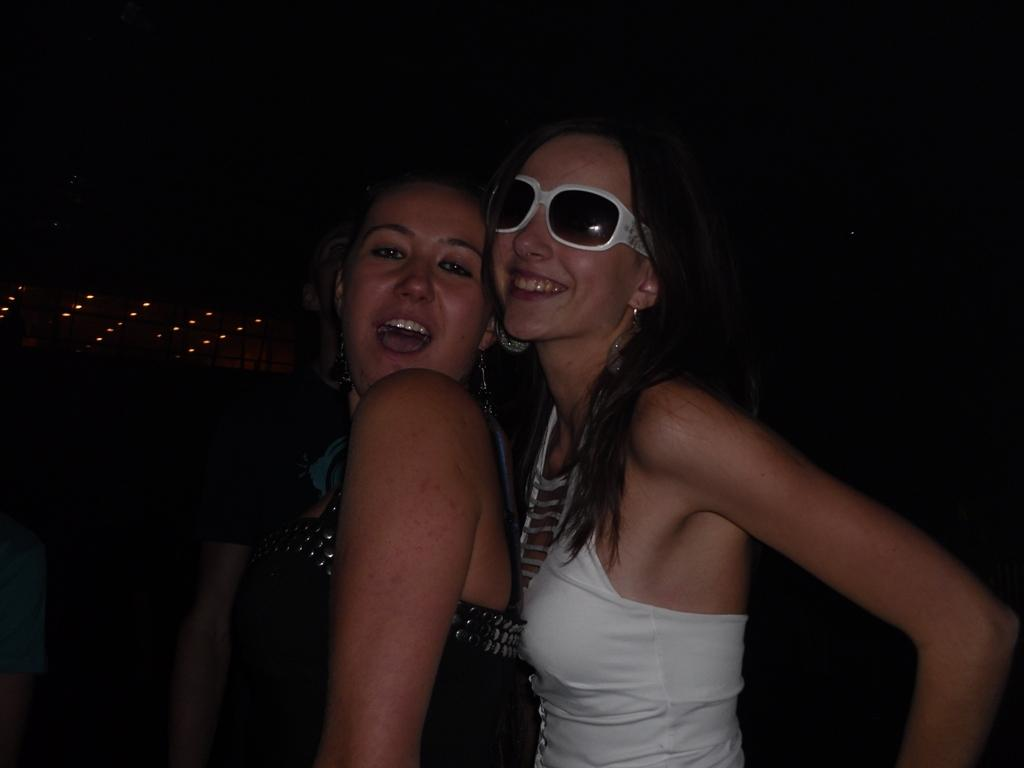How many people are in the image? There are three people in the image. What colors are the people wearing? The people are wearing white and black color dresses. Can you describe any specific accessory one of the people is wearing? One person is wearing goggles. What can be seen in the background of the image? There are lights visible in the background. What is the color of the background in the image? The background is black. How long does the journey take for the person wearing the goggles in the image? There is no information about a journey in the image, so it cannot be determined how long it takes. What type of quiver is visible in the image? There is no quiver present in the image. 